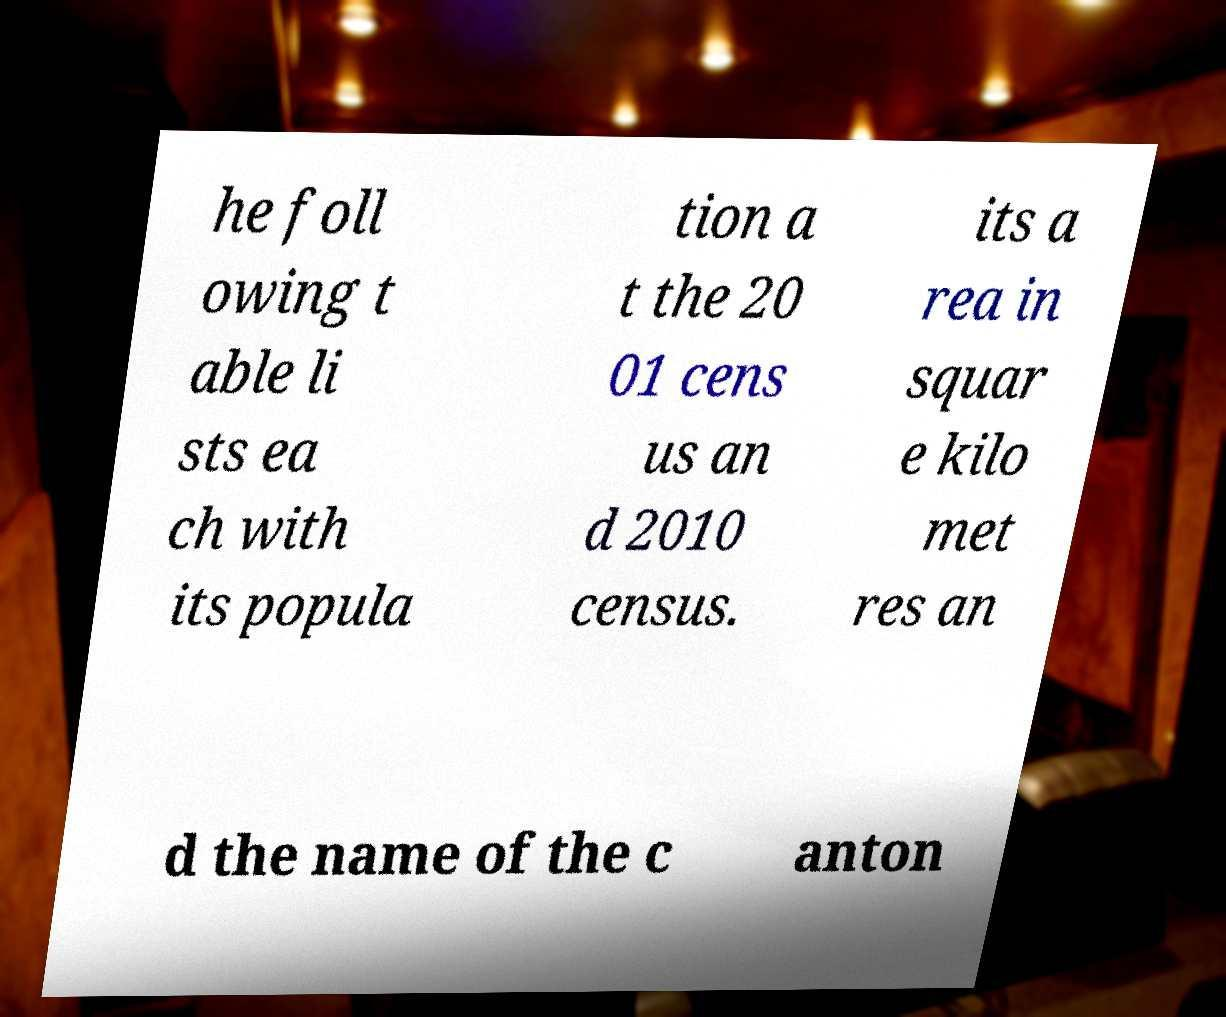Can you read and provide the text displayed in the image?This photo seems to have some interesting text. Can you extract and type it out for me? he foll owing t able li sts ea ch with its popula tion a t the 20 01 cens us an d 2010 census. its a rea in squar e kilo met res an d the name of the c anton 